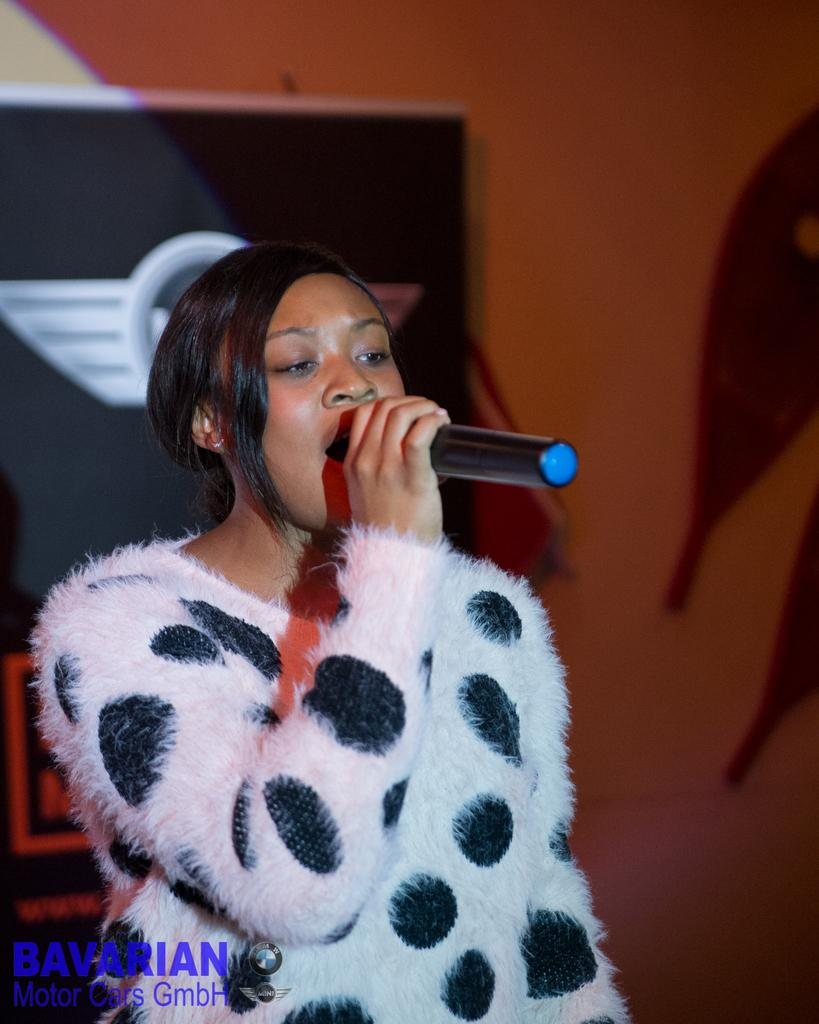Who is the main subject in the image? There is a woman in the image. What is the woman holding in the image? The woman is holding a microphone. What is the woman doing in the image? The woman is singing. What can be seen in the background of the image? There are boards on the wall in the background of the image. What type of silk fabric is draped over the woman's shoulders in the image? There is no silk fabric present in the image; the woman is holding a microphone and singing. 